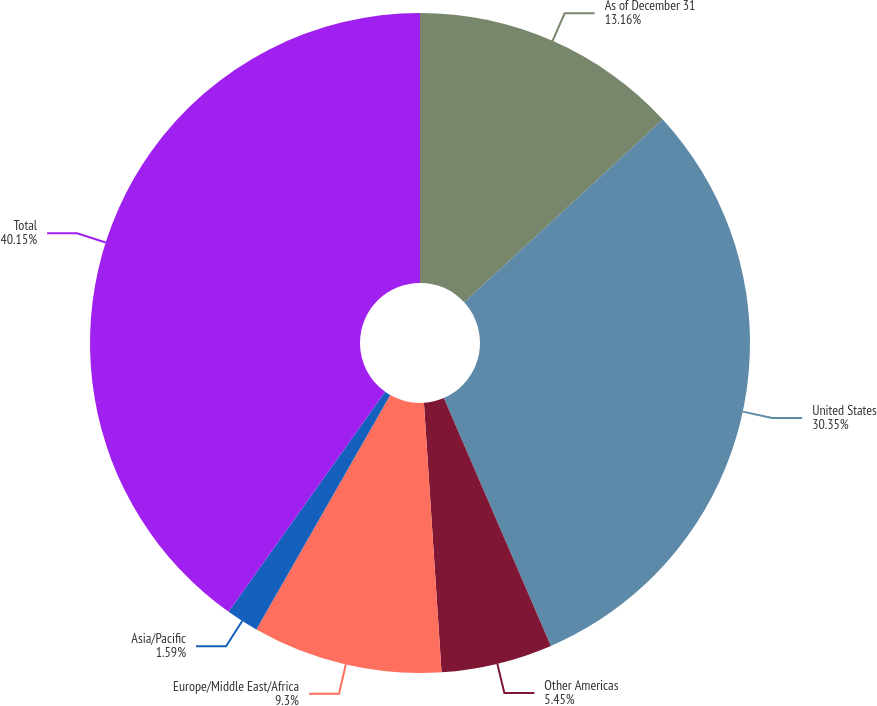Convert chart to OTSL. <chart><loc_0><loc_0><loc_500><loc_500><pie_chart><fcel>As of December 31<fcel>United States<fcel>Other Americas<fcel>Europe/Middle East/Africa<fcel>Asia/Pacific<fcel>Total<nl><fcel>13.16%<fcel>30.35%<fcel>5.45%<fcel>9.3%<fcel>1.59%<fcel>40.15%<nl></chart> 